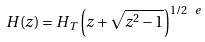Convert formula to latex. <formula><loc_0><loc_0><loc_500><loc_500>H ( z ) = H _ { T } \left ( z + \sqrt { z ^ { 2 } - 1 } \right ) ^ { 1 / 2 \ e }</formula> 